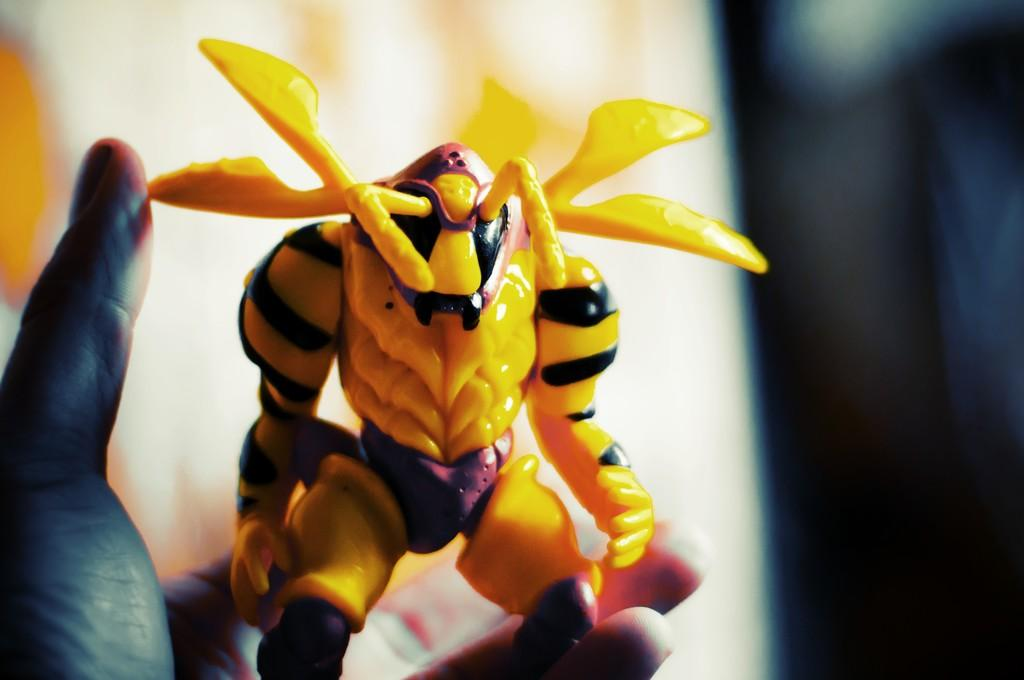What is the person in the image doing? The person is holding a toy in their hand. Can you describe the background of the image? There are lights visible in the background of the image, and both white and dark colors are present. What might be the setting of the image? The image may have been taken in a room. Can you tell me how many rods the person is holding in the image? There is no rod present in the image; the person is holding a toy. What type of property is visible in the background of the image? There is no property visible in the image; the background consists of lights and colors. 